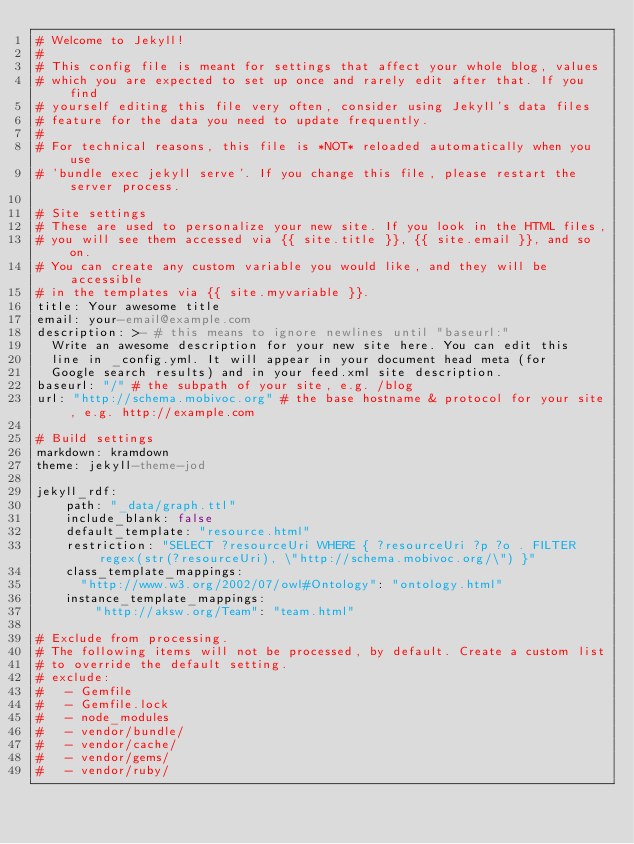<code> <loc_0><loc_0><loc_500><loc_500><_YAML_># Welcome to Jekyll!
#
# This config file is meant for settings that affect your whole blog, values
# which you are expected to set up once and rarely edit after that. If you find
# yourself editing this file very often, consider using Jekyll's data files
# feature for the data you need to update frequently.
#
# For technical reasons, this file is *NOT* reloaded automatically when you use
# 'bundle exec jekyll serve'. If you change this file, please restart the server process.

# Site settings
# These are used to personalize your new site. If you look in the HTML files,
# you will see them accessed via {{ site.title }}, {{ site.email }}, and so on.
# You can create any custom variable you would like, and they will be accessible
# in the templates via {{ site.myvariable }}.
title: Your awesome title
email: your-email@example.com
description: >- # this means to ignore newlines until "baseurl:"
  Write an awesome description for your new site here. You can edit this
  line in _config.yml. It will appear in your document head meta (for
  Google search results) and in your feed.xml site description.
baseurl: "/" # the subpath of your site, e.g. /blog
url: "http://schema.mobivoc.org" # the base hostname & protocol for your site, e.g. http://example.com

# Build settings
markdown: kramdown
theme: jekyll-theme-jod

jekyll_rdf:
    path: "_data/graph.ttl"
    include_blank: false
    default_template: "resource.html"
    restriction: "SELECT ?resourceUri WHERE { ?resourceUri ?p ?o . FILTER regex(str(?resourceUri), \"http://schema.mobivoc.org/\") }"
    class_template_mappings:
      "http://www.w3.org/2002/07/owl#Ontology": "ontology.html"
    instance_template_mappings:
        "http://aksw.org/Team": "team.html"

# Exclude from processing.
# The following items will not be processed, by default. Create a custom list
# to override the default setting.
# exclude:
#   - Gemfile
#   - Gemfile.lock
#   - node_modules
#   - vendor/bundle/
#   - vendor/cache/
#   - vendor/gems/
#   - vendor/ruby/
</code> 